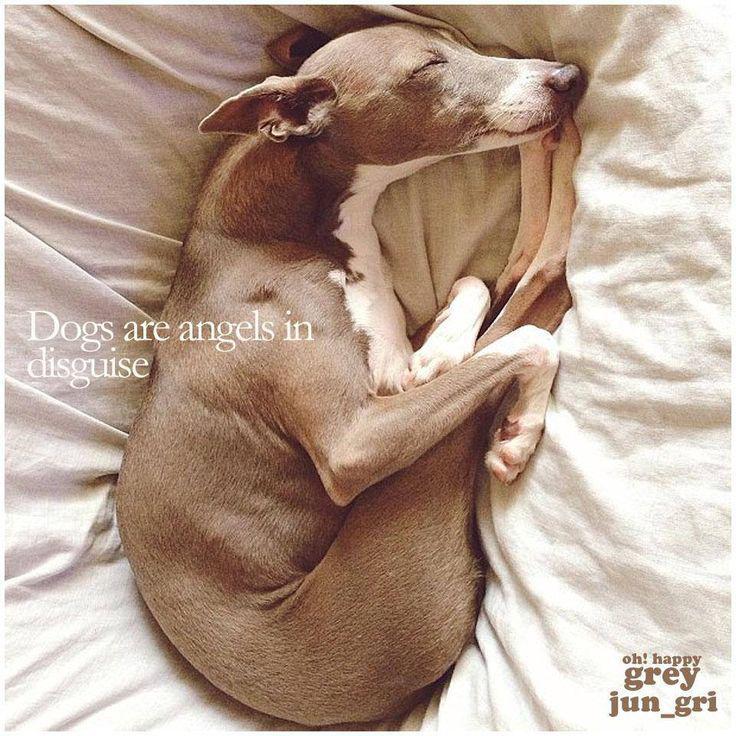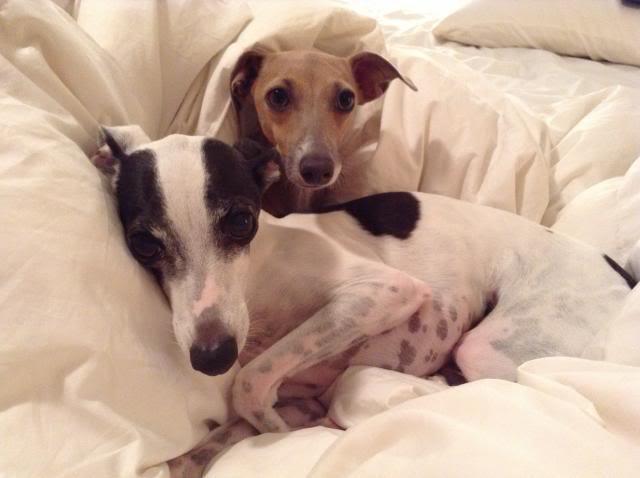The first image is the image on the left, the second image is the image on the right. Evaluate the accuracy of this statement regarding the images: "An image contains one leftward-facing snoozing brown dog, snuggled with folds of blanket and no human present.". Is it true? Answer yes or no. No. The first image is the image on the left, the second image is the image on the right. For the images displayed, is the sentence "There are two dogs and zero humans, and the dog on the right is laying on a blanket." factually correct? Answer yes or no. No. 